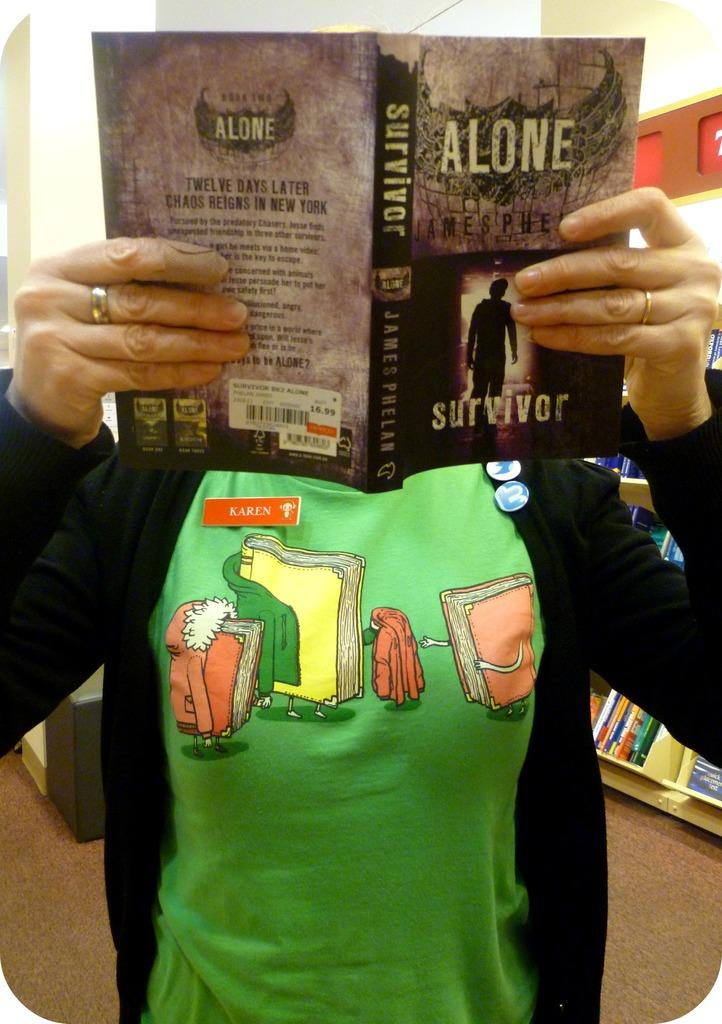Provide a one-sentence caption for the provided image. A woman holding a book titled Alone, with the word Survivor at the bottom. 